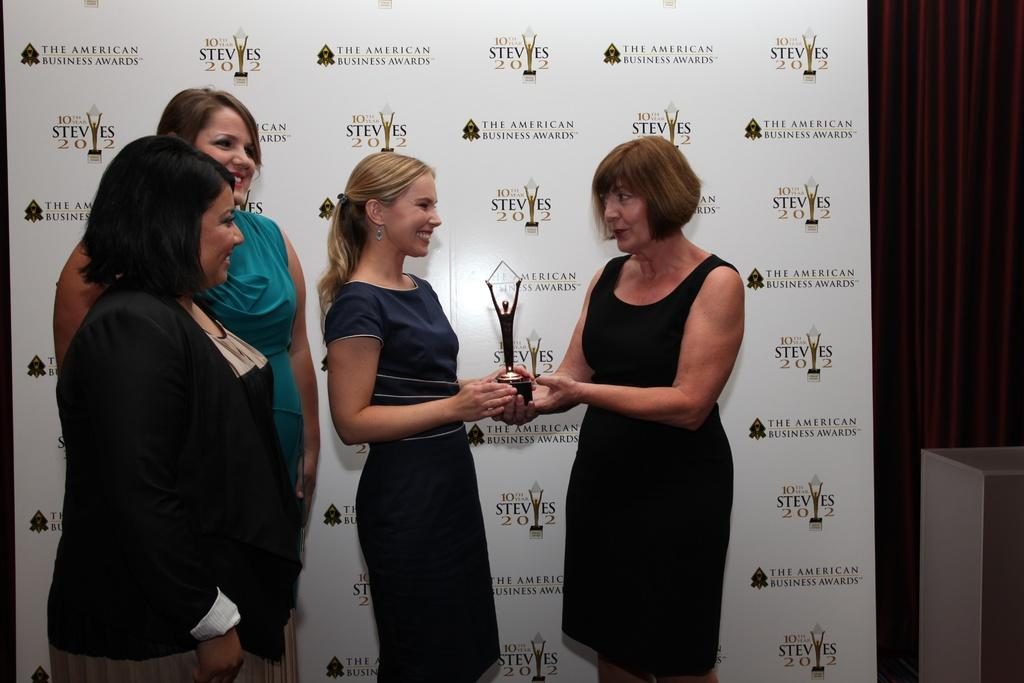How many women are present in the image? There are four women standing in the image. What are the women wearing? The women are wearing clothes. What object can be seen in the image that might be associated with an achievement or competition? There is a trophy in the image. What type of accessory is visible in the image? There is an ear stud in the image. What is hanging on the wall in the image? There is a poster in the image. What type of vase is visible in the image? There is no vase present in the image. How does the ear stud stop the women from talking in the image? The ear stud does not have any effect on the women's ability to talk; it is simply an accessory they are wearing. 